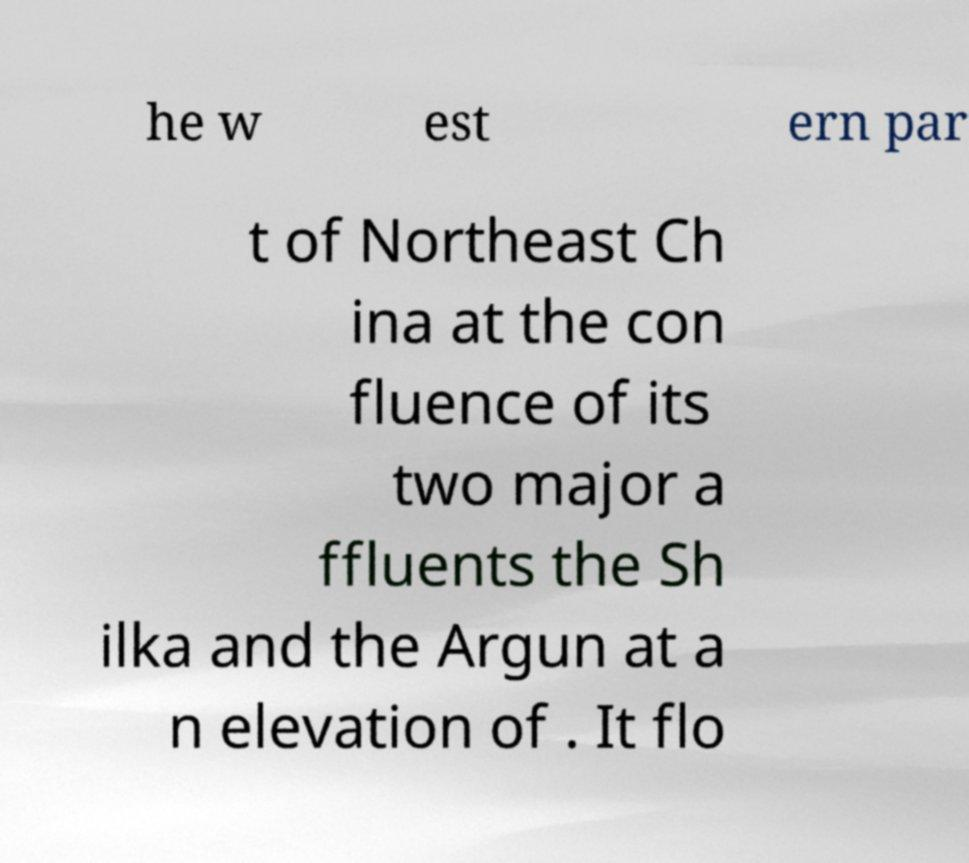For documentation purposes, I need the text within this image transcribed. Could you provide that? he w est ern par t of Northeast Ch ina at the con fluence of its two major a ffluents the Sh ilka and the Argun at a n elevation of . It flo 